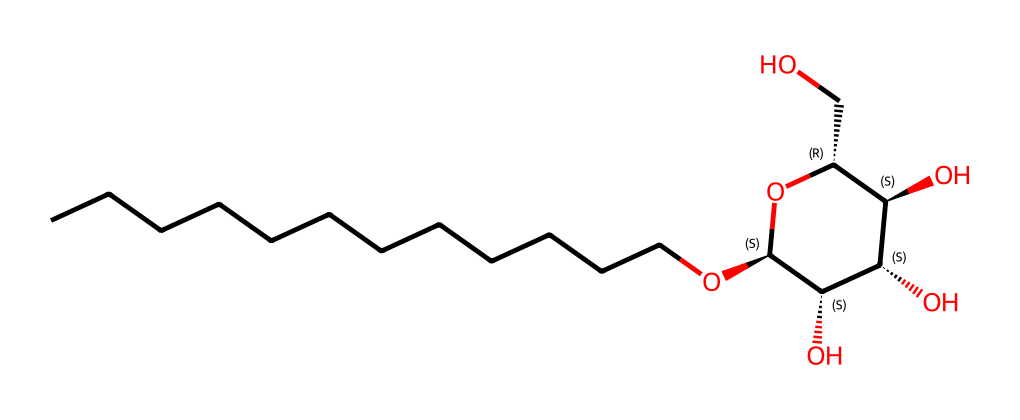What is the molecular formula of this surfactant? To determine the molecular formula, we count the carbon (C), hydrogen (H), and oxygen (O) atoms present in the SMILES representation. There are 16 carbons, 32 hydrogens, and 6 oxygens. Thus, the molecular formula is C16H32O6.
Answer: C16H32O6 How many hydroxyl groups are present in this structure? By examining the structure represented in the SMILES, we can see that there are three -OH (hydroxyl) groups indicated by the presence of oxygen atoms connected to hydrogen atoms.
Answer: 3 What is the significance of the alkyl chain length in this surfactant? The alkyl chain (represented by the sequence of C's) significantly influences the surfactant's solubility and emulsifying properties. Longer chains generally improve oil solubility, which is desirable for cleaning products.
Answer: it improves oil solubility Does this surfactant contain a chiral center? In the provided structure, we can identify chiral centers by looking for carbon atoms bonded to four different groups. The presence of two such carbon atoms (indicated by @ symbols in the SMILES) confirms chirality.
Answer: yes What characterizes alkyl polyglucosides as eco-friendly surfactants? Alkyl polyglucosides are derived from renewable sources and are biodegradable; they typically have a low environmental impact, making them suitable for green cleaning products.
Answer: renewable and biodegradable 